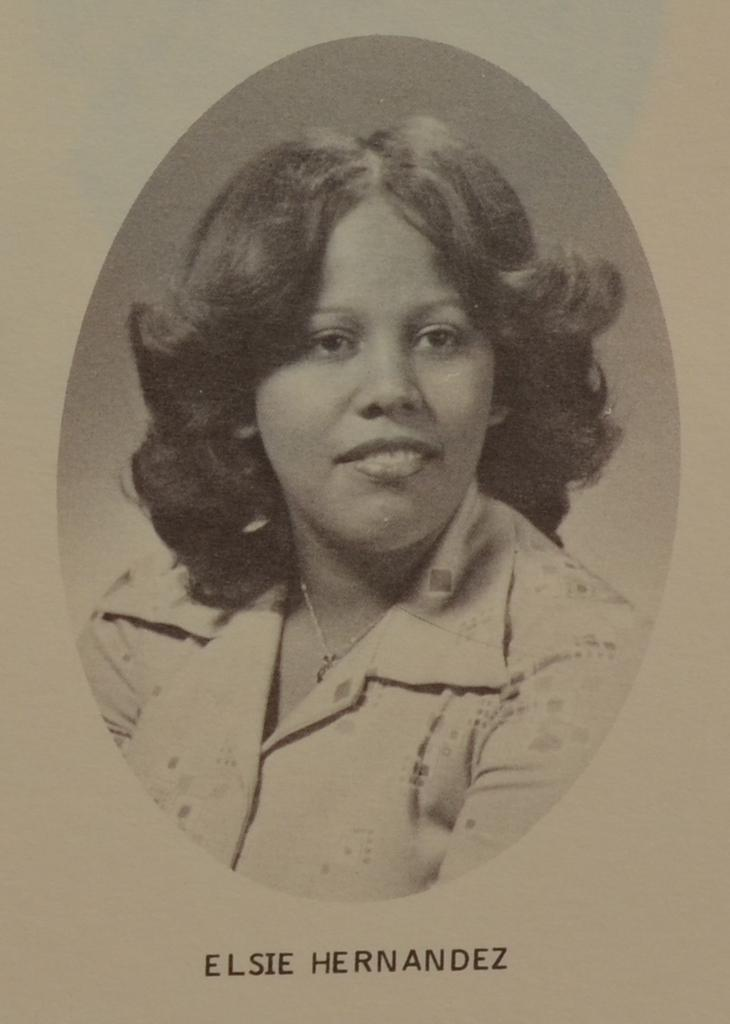What is featured on the image in the poster in the image? The poster contains a picture of a woman. What else can be seen on the poster besides the image? There is text at the bottom of the poster. How many giraffes can be seen in the image? There are no giraffes present in the image; it features a poster with a picture of a woman. What type of mouth does the bee have in the image? There is no bee present in the image, so it is not possible to determine the type of mouth it might have. 